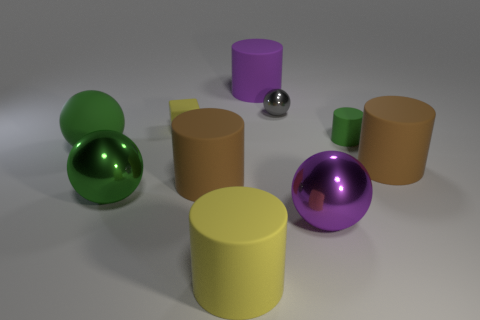What kind of lighting is being used to illuminate the objects in the scene? The objects in the scene are lit by a soft, diffuse overhead light, creating gentle shadows and highlights that subtly define their forms without causing harsh contrasts. 